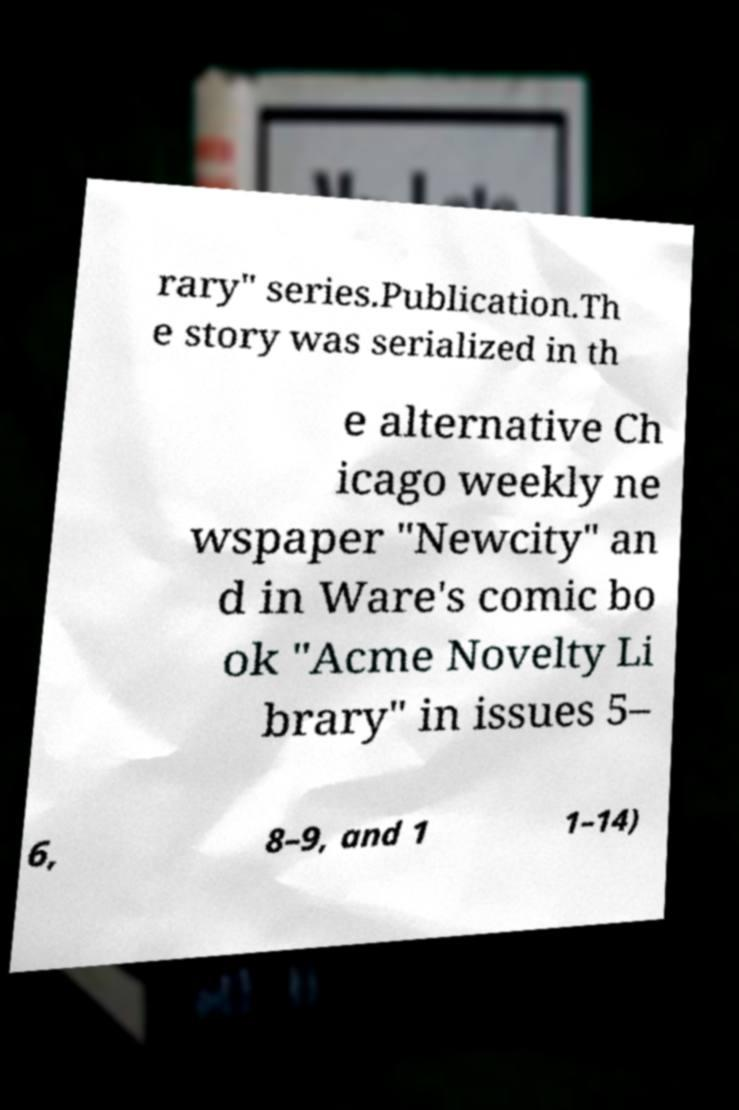Please read and relay the text visible in this image. What does it say? rary" series.Publication.Th e story was serialized in th e alternative Ch icago weekly ne wspaper "Newcity" an d in Ware's comic bo ok "Acme Novelty Li brary" in issues 5– 6, 8–9, and 1 1–14) 